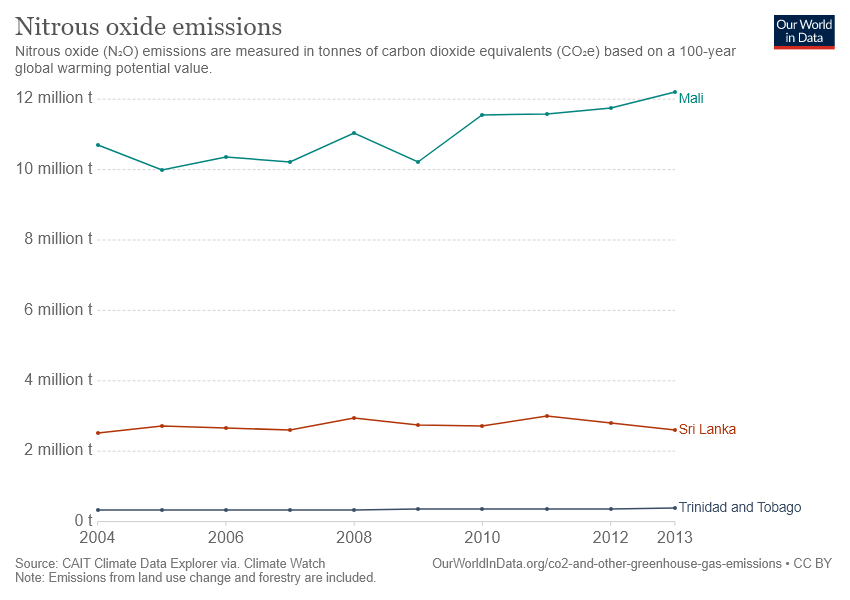Identify some key points in this picture. In 2005, the gap between Sri Lanka and Mali was the smallest. The green line represents the country of Mali. 